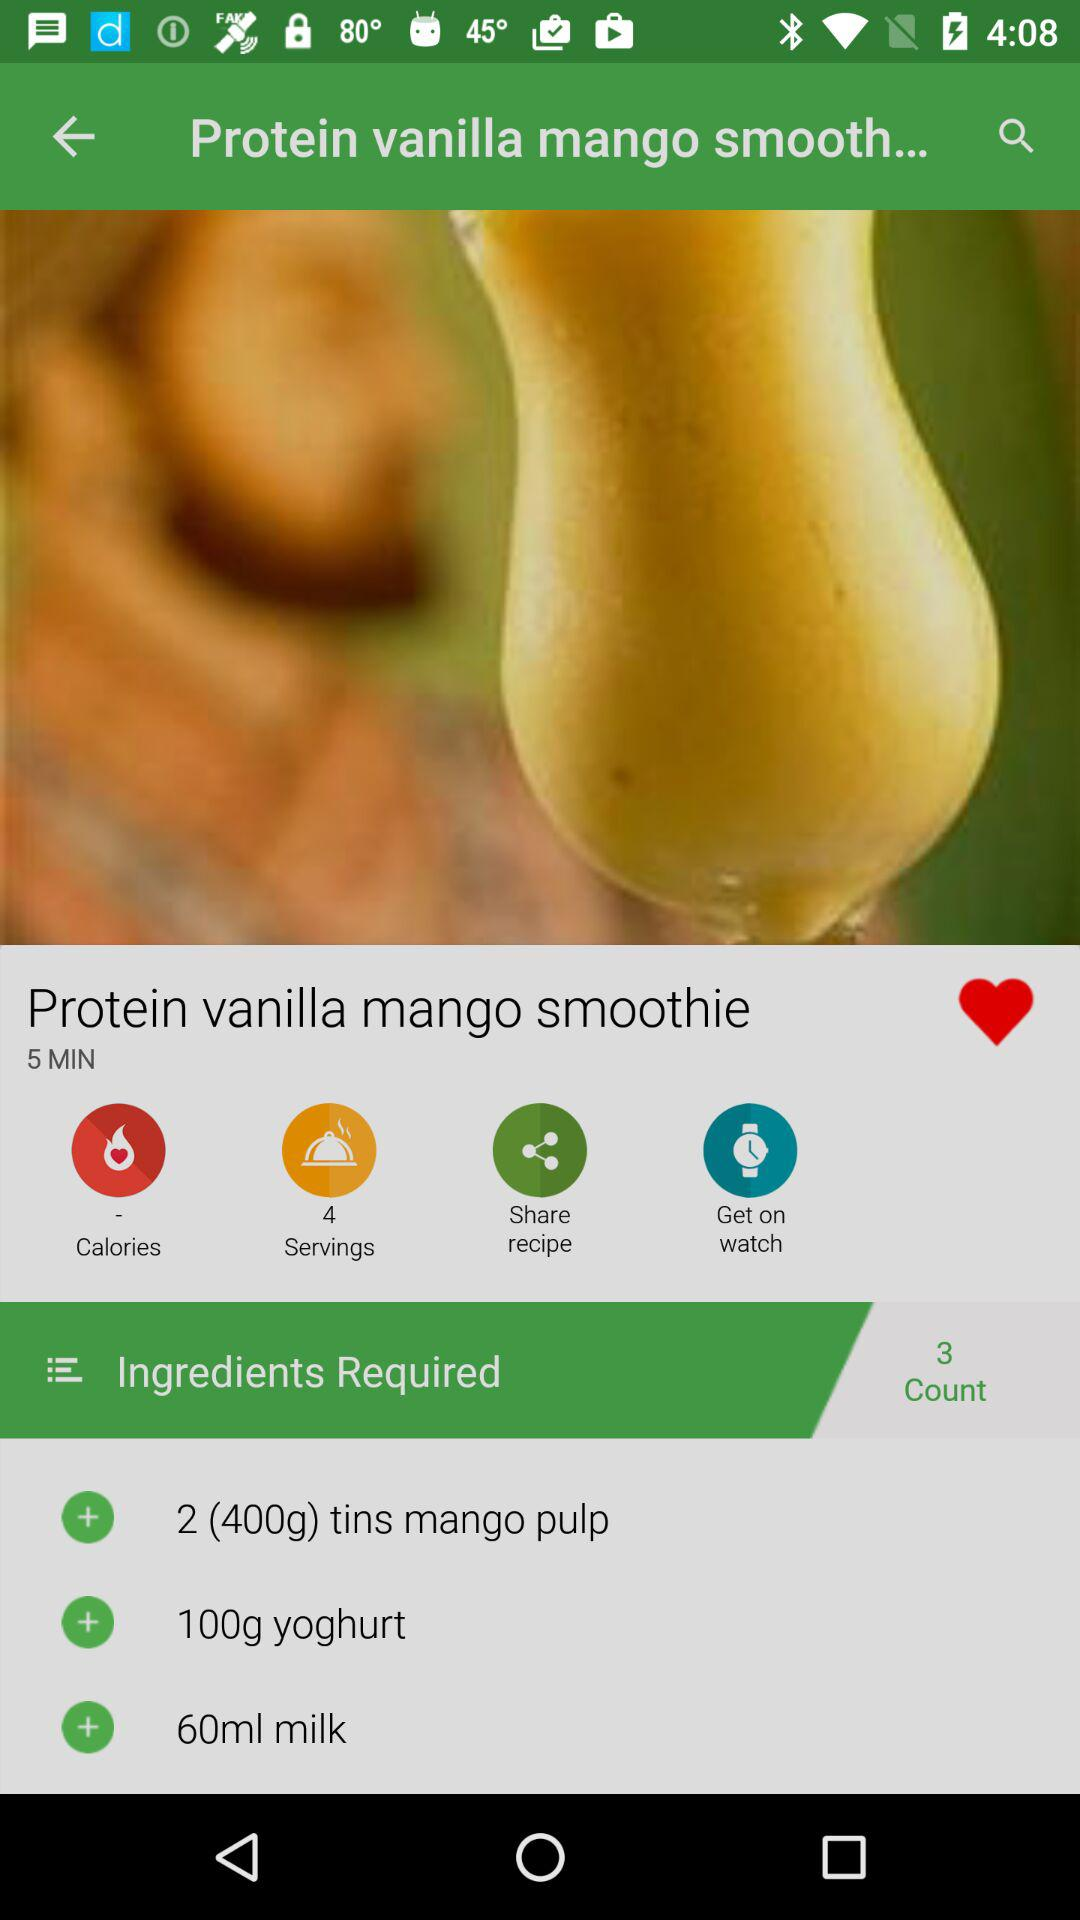How much milk is required? The milk required is 60 ml. 